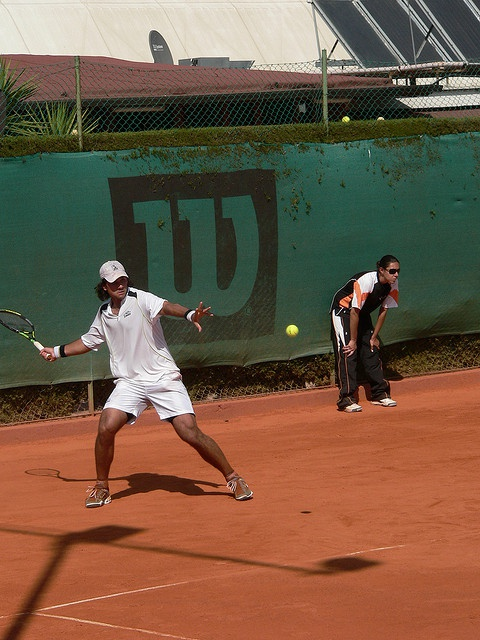Describe the objects in this image and their specific colors. I can see people in lightgray, maroon, darkgray, and brown tones, people in lightgray, black, maroon, and brown tones, tennis racket in lightgray, gray, black, and darkgreen tones, sports ball in lightgray, khaki, and olive tones, and sports ball in lightgray, khaki, olive, and darkgreen tones in this image. 